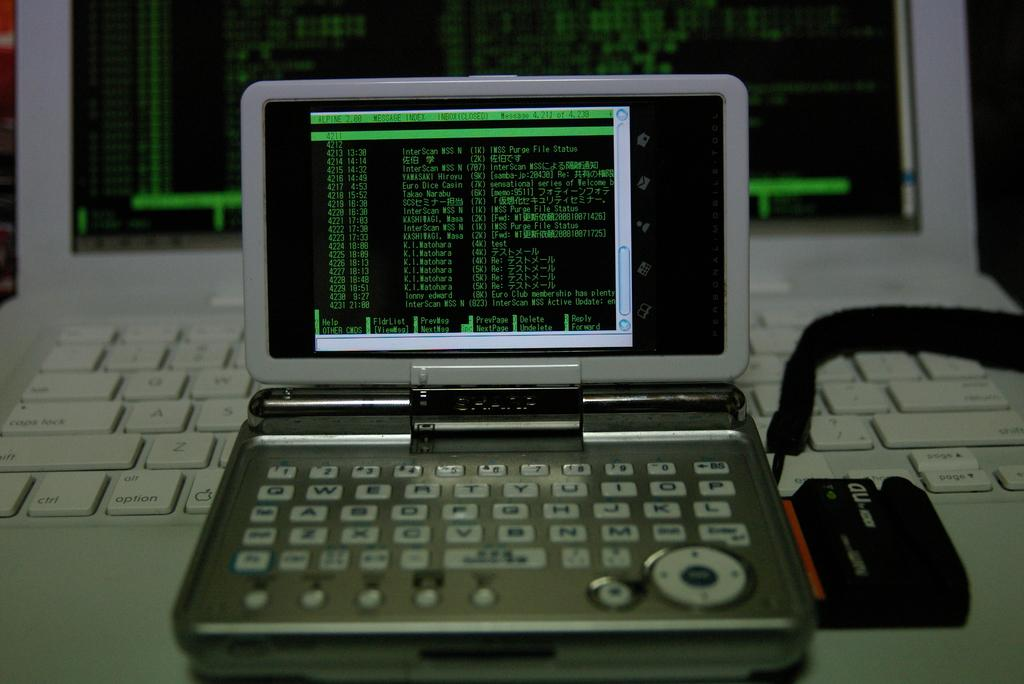Provide a one-sentence caption for the provided image. A computer monitor with Message Index written on the screen. 